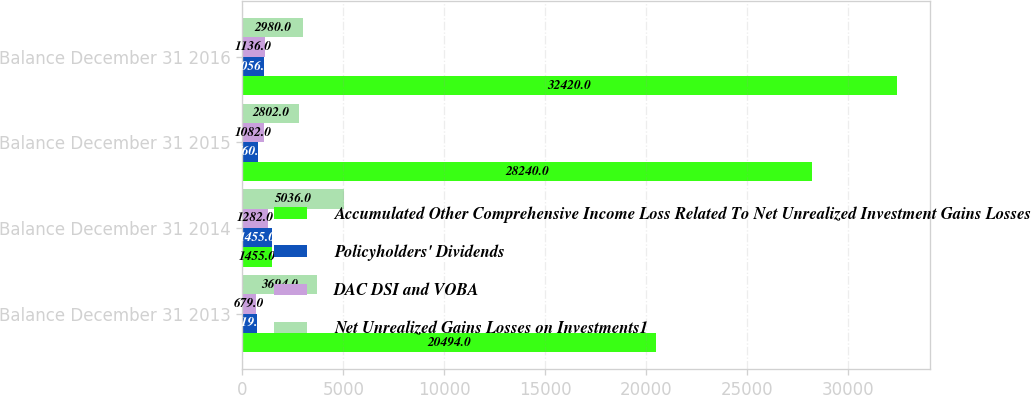<chart> <loc_0><loc_0><loc_500><loc_500><stacked_bar_chart><ecel><fcel>Balance December 31 2013<fcel>Balance December 31 2014<fcel>Balance December 31 2015<fcel>Balance December 31 2016<nl><fcel>Accumulated Other Comprehensive Income Loss Related To Net Unrealized Investment Gains Losses<fcel>20494<fcel>1455<fcel>28240<fcel>32420<nl><fcel>Policyholders' Dividends<fcel>719<fcel>1455<fcel>760<fcel>1056<nl><fcel>DAC DSI and VOBA<fcel>679<fcel>1282<fcel>1082<fcel>1136<nl><fcel>Net Unrealized Gains Losses on Investments1<fcel>3694<fcel>5036<fcel>2802<fcel>2980<nl></chart> 